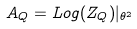Convert formula to latex. <formula><loc_0><loc_0><loc_500><loc_500>A _ { Q } = L o g ( Z _ { Q } ) | _ { \theta ^ { 2 } }</formula> 